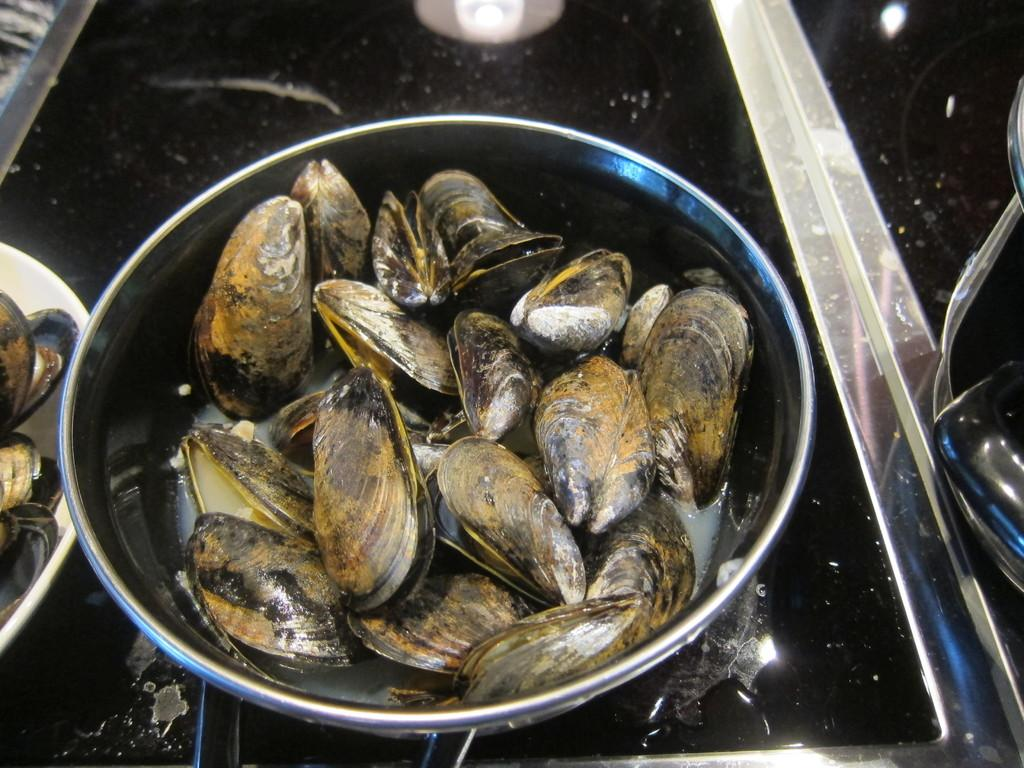What objects are on the surface in the image? There are bowls on a surface in the image. What is inside the bowls? There are oysters in the bowls. Are there any people or toys visible in the image? No, there are no people or toys visible in the image. Is there a book present in the image? No, there is no book present in the image. 